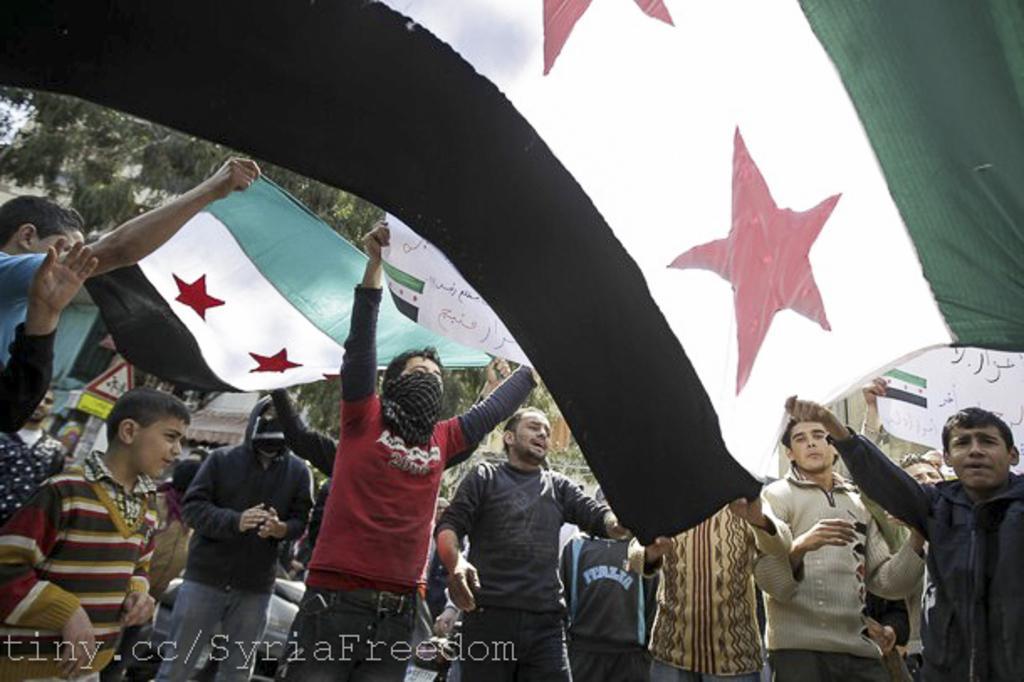Please provide a concise description of this image. Here we can see group of people protesting with play cards and flags in their hands and we can see trees behind them 